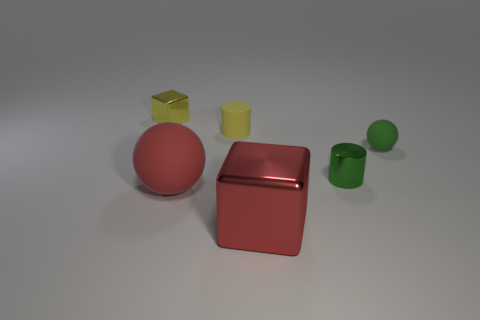What number of metal things are either red cubes or small green cylinders?
Offer a terse response. 2. The tiny shiny thing right of the tiny matte thing behind the tiny green thing behind the green metallic cylinder is what color?
Your response must be concise. Green. What color is the small metallic thing that is the same shape as the large red metallic thing?
Offer a very short reply. Yellow. Is there anything else that has the same color as the tiny cube?
Give a very brief answer. Yes. How many other things are the same material as the small block?
Provide a short and direct response. 2. How big is the yellow matte cylinder?
Give a very brief answer. Small. Is there a red rubber object of the same shape as the green matte thing?
Provide a short and direct response. Yes. How many objects are either cyan matte spheres or yellow shiny blocks to the left of the small yellow rubber thing?
Make the answer very short. 1. What color is the matte sphere on the right side of the yellow rubber object?
Ensure brevity in your answer.  Green. Does the yellow object that is in front of the small yellow block have the same size as the cylinder right of the large red metal block?
Make the answer very short. Yes. 